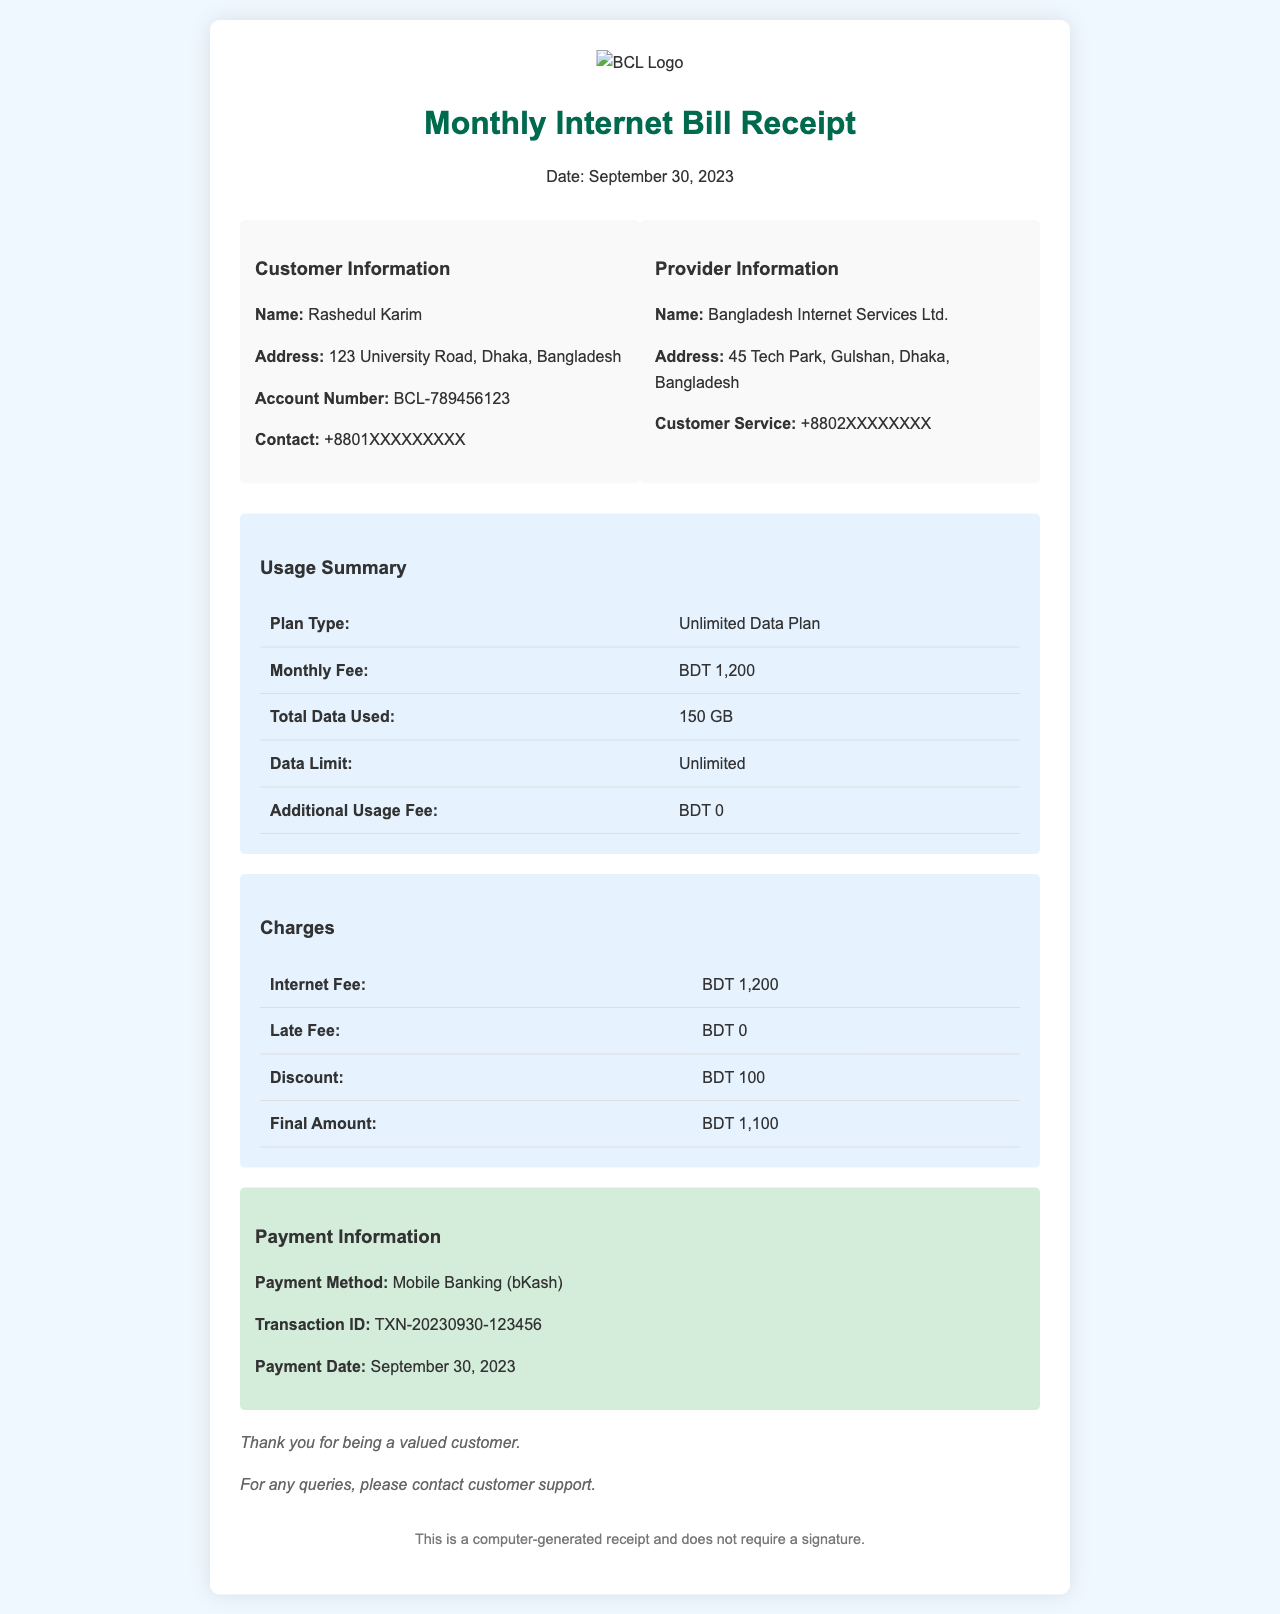What is the customer's name? The customer's name is provided in the document under Customer Information.
Answer: Rashedul Karim What is the total data used? The total data used is specified in the Usage Summary section of the receipt.
Answer: 150 GB What is the final amount charged? The final amount charged is located in the Charges section of the document.
Answer: BDT 1,100 What is the payment method? The payment method is mentioned in the Payment Information section of the receipt.
Answer: Mobile Banking (bKash) What is the plan type? The plan type for the internet service is found in the Usage Summary section.
Answer: Unlimited Data Plan What discount was applied? The discount applied is provided in the Charges section of the receipt.
Answer: BDT 100 What is the date of the receipt? The date of the receipt is stated in the header section.
Answer: September 30, 2023 Where is the service provider located? The location of the service provider is given under Provider Information.
Answer: 45 Tech Park, Gulshan, Dhaka, Bangladesh Was there any late fee charged? The late fee charged is detailed in the Charges section of the document.
Answer: BDT 0 